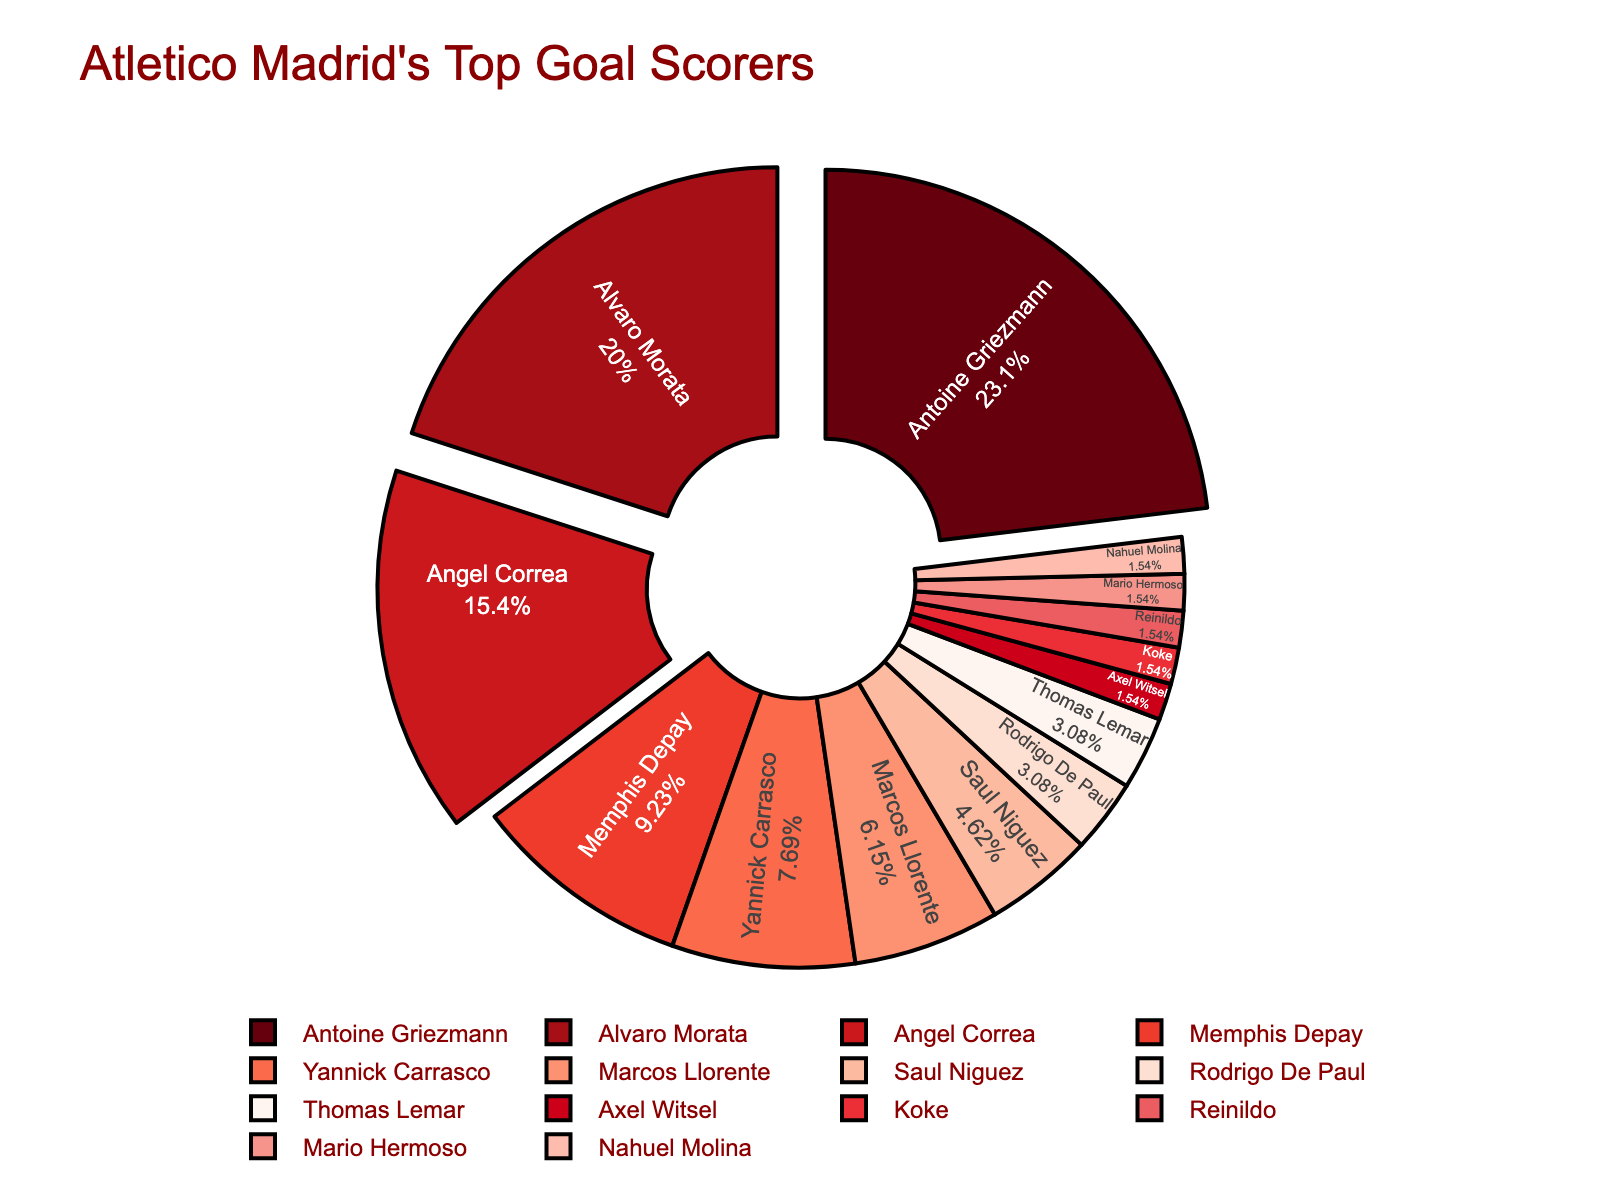Which player scored the most goals for Atletico Madrid last season? By looking at the distribution of goals in the pie chart, the largest section represents the player with the most goals.
Answer: Antoine Griezmann How many goals did Antoine Griezmann and Alvaro Morata score combined? Refer to the values associated with Antoine Griezmann and Alvaro Morata, then sum them up. Griezmann scored 15 goals and Morata scored 13 goals, so 15 + 13 = 28.
Answer: 28 What percentage of the total goals were scored by Angel Correa? Identify the section of the pie chart corresponding to Angel Correa and read the percentage label inside it.
Answer: 13.3% Who scored more goals, Yannick Carrasco or Marcos Llorente? Compare the sizes of the pie chart sections respective to Yannick Carrasco and Marcos Llorente, noting that Carrasco's section is larger.
Answer: Yannick Carrasco Which three players scored the least number of goals? Look at the smallest sections of the pie chart. The smallest three sections represent players who scored 1 goal each: Axel Witsel, Koke, and Reinildo.
Answer: Axel Witsel, Koke, Reinildo What is the difference in the number of goals between the top and bottom goal scorers? Antoine Griezmann scored the most goals with 15, while multiple players scored the least with 1 goal each. The difference is 15 - 1 = 14 goals.
Answer: 14 What proportion of the total goals were scored by the top three scorers combined? Sum the goals of the top three players: Antoine Griezmann (15), Alvaro Morata (13), and Angel Correa (10), then divide by the total number of goals. The combined total is 38 goals. The total number of goals scored is 64, so the proportion is 38/64 ≈ 59.4%.
Answer: 59.4% How many players scored more than 5 goals? Identify the sections larger than the one representing 5 goals to count the players: Antoine Griezmann, Alvaro Morata, and Angel Correa.
Answer: 3 Which player's section appears closest to the center of the pie chart due to its low value? Sections with the lowest values are pulled towards the center. Axel Witsel, Koke, Reinildo, Mario Hermoso, and Nahuel Molina each scored 1 goal.
Answer: Axel Witsel, Koke, Reinildo, Mario Hermoso, Nahuel Molina What is the average number of goals scored by players who scored exactly 1 goal? Count the players with exactly 1 goal, which is 5 players. The total number of goals for these players is 1 * 5 = 5. The average is 5/5 = 1 goal per player.
Answer: 1 